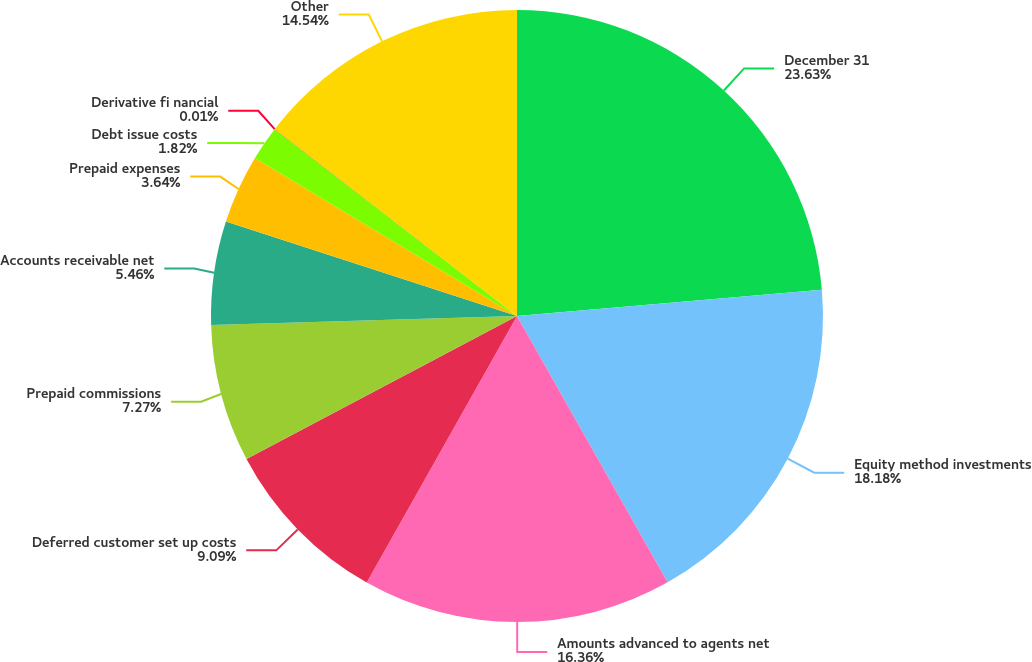<chart> <loc_0><loc_0><loc_500><loc_500><pie_chart><fcel>December 31<fcel>Equity method investments<fcel>Amounts advanced to agents net<fcel>Deferred customer set up costs<fcel>Prepaid commissions<fcel>Accounts receivable net<fcel>Prepaid expenses<fcel>Debt issue costs<fcel>Derivative fi nancial<fcel>Other<nl><fcel>23.63%<fcel>18.18%<fcel>16.36%<fcel>9.09%<fcel>7.27%<fcel>5.46%<fcel>3.64%<fcel>1.82%<fcel>0.01%<fcel>14.54%<nl></chart> 